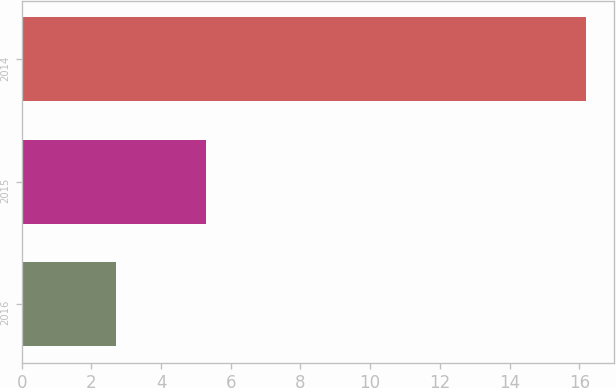<chart> <loc_0><loc_0><loc_500><loc_500><bar_chart><fcel>2016<fcel>2015<fcel>2014<nl><fcel>2.7<fcel>5.3<fcel>16.2<nl></chart> 